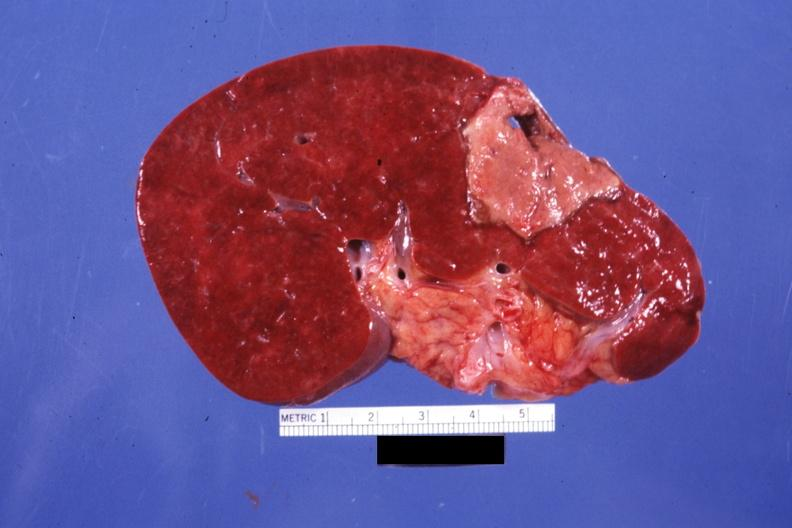what is present?
Answer the question using a single word or phrase. Spleen 